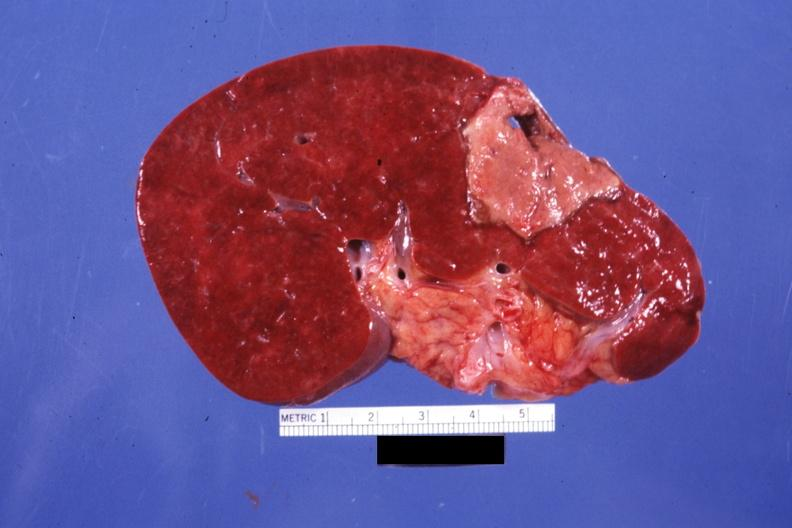what is present?
Answer the question using a single word or phrase. Spleen 